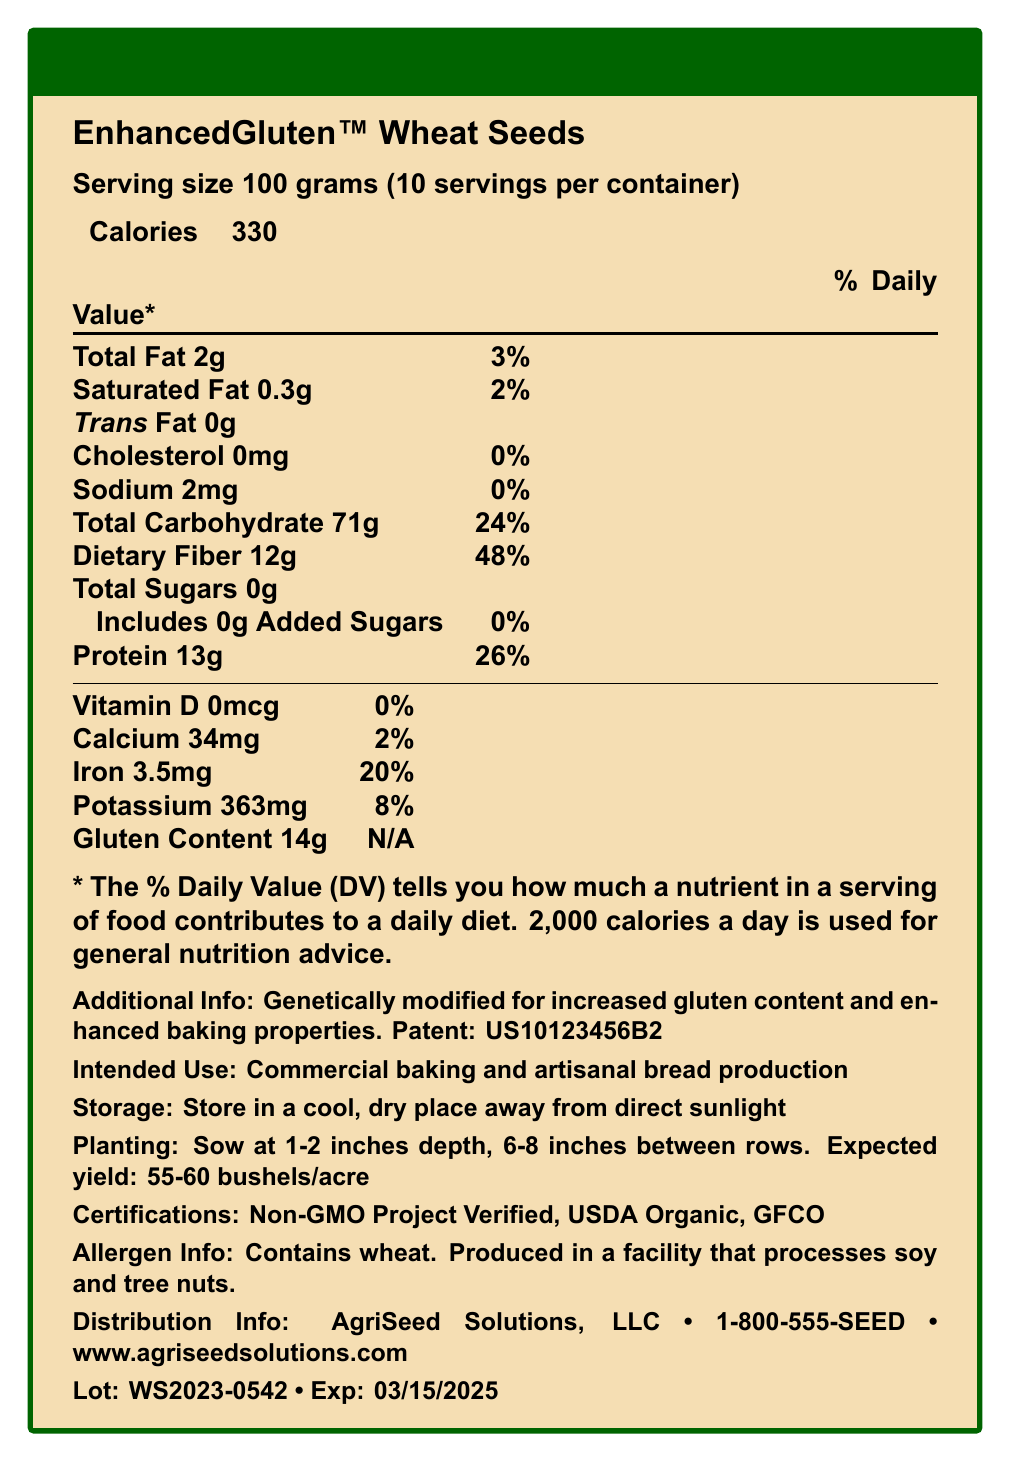what is the serving size of EnhancedGluten™ Wheat Seeds? The document specifies the serving size as 100 grams.
Answer: 100 grams how many calories are there per serving? The document states that there are 330 calories per serving.
Answer: 330 how much fat is in one serving? The document indicates that the total fat in one serving is 2 grams.
Answer: 2g what is the germination rate of these wheat seeds? The additional info section of the document mentions that the germination rate is 95%.
Answer: 95% what is the recommended fertilizer for planting these seeds? The additional info section states that the recommended fertilizer is a balanced NPK 14-14-14 with trace minerals.
Answer: Balanced NPK 14-14-14 with trace minerals where should the wheat seeds be stored? The storage instructions specify that the seeds should be stored in a cool, dry place away from direct sunlight.
Answer: In a cool, dry place away from direct sunlight Is EnhancedGluten™ Wheat Seeds certified as USDA Organic? The certification section of the document lists USDA Organic as one of its certifications.
Answer: Yes What is the primary characteristic genetically modified in EnhancedGluten™ Wheat Seeds? A. Increased nutrient content B. Increased gluten content C. Pest resistance D. Drought tolerance The document clearly states that the wheat seeds are genetically modified for increased gluten content for enhanced baking properties.
Answer: B How many servings are in one container of EnhancedGluten™ Wheat Seeds? A. 8 B. 10 C. 12 D. 15 The document mentions that there are 10 servings per container.
Answer: B Which nutrient has the highest daily value percentage in EnhancedGluten™ Wheat Seeds? A. Total Fat B. Protein C. Dietary Fiber D. Iron The document shows that dietary fiber has the highest daily value percentage at 48%.
Answer: C Do these seeds contain added sugars? The document specifies that the seeds contain 0g of added sugars.
Answer: No Summarize the key nutritional information and intended use of EnhancedGluten™ Wheat Seeds. The document provides detailed nutritional information per serving, the main genetic modification for gluten enhancement for baking, and various usage, storage, and certification details.
Answer: EnhancedGluten™ Wheat Seeds are genetically modified for increased gluten content, primarily for commercial baking and artisanal bread production. Each 100-gram serving contains 330 calories, 2g of fat, 71g of carbohydrates with 12g dietary fiber, 13g of protein, and essential minerals such as calcium, iron, and potassium. The seeds are certified USDA Organic and Non-GMO. They should be stored in a cool, dry place and have a germination rate of 95%. What is the protein content in flour made from these seeds? The document does not provide specific details on the protein content in the derived flour.
Answer: Cannot be determined 